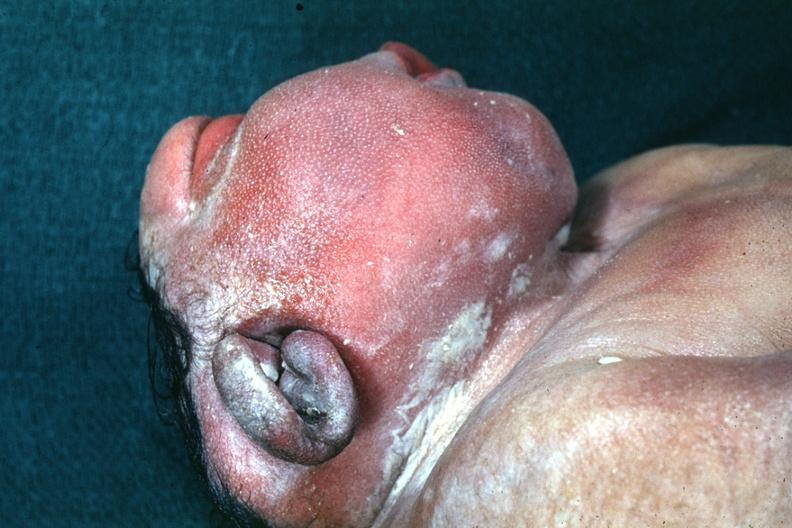does this image show lateral view of head typical example?
Answer the question using a single word or phrase. Yes 